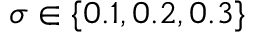<formula> <loc_0><loc_0><loc_500><loc_500>\sigma \in \{ 0 . 1 , 0 . 2 , 0 . 3 \}</formula> 